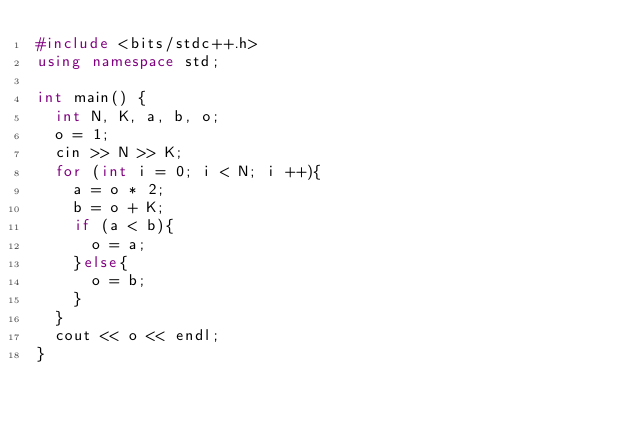Convert code to text. <code><loc_0><loc_0><loc_500><loc_500><_C++_>#include <bits/stdc++.h>
using namespace std;

int main() {
  int N, K, a, b, o;
  o = 1;
  cin >> N >> K;
  for (int i = 0; i < N; i ++){
    a = o * 2;
    b = o + K;
    if (a < b){
      o = a;
    }else{
      o = b;
    }
  }
  cout << o << endl;
}</code> 